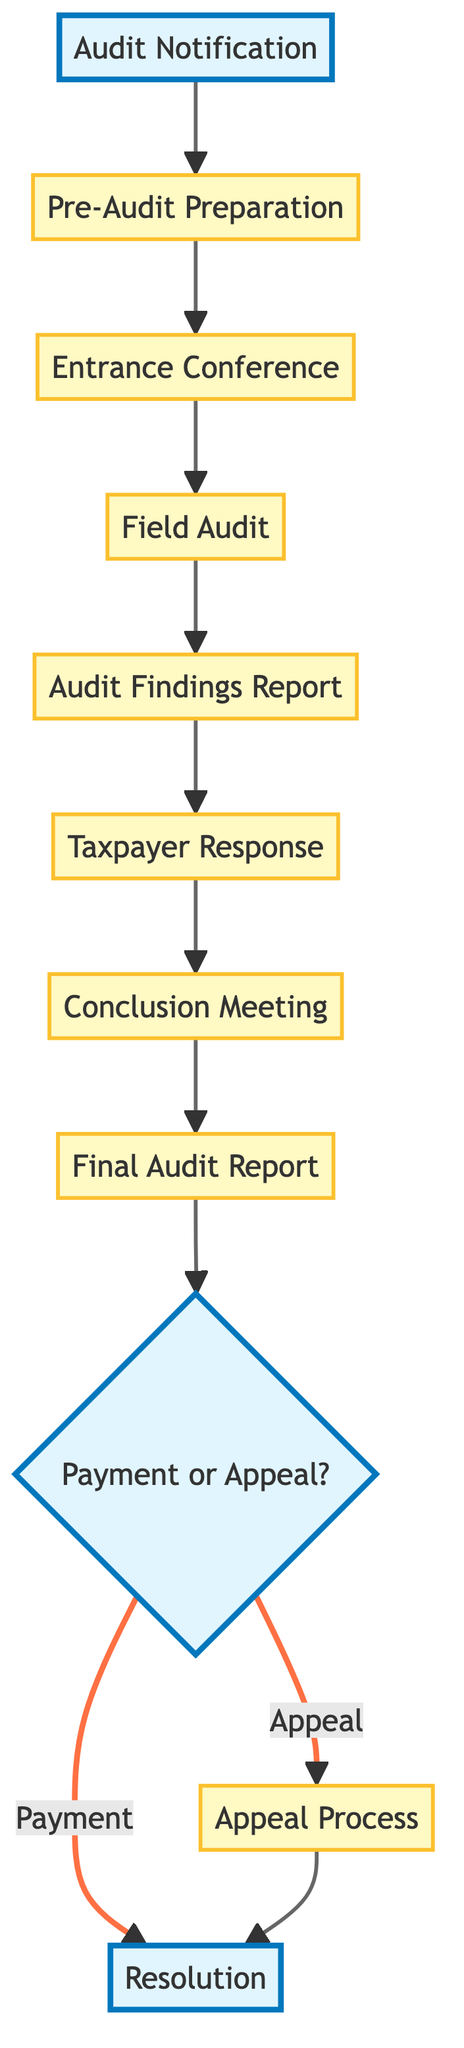What is the first stage of the tax audit procedure? The diagram indicates the first stage of the tax audit procedure is "Audit Notification," which is represented as the starting point in the flow chart.
Answer: Audit Notification How many stages are in the tax audit procedure? By counting the nodes in the flow chart, there are a total of 11 distinct stages listed, from "Audit Notification" to "Resolution."
Answer: 11 What happens after the "Field Audit"? According to the flow chart, after the "Field Audit" stage, the next stage is "Audit Findings Report," which follows directly in the flow.
Answer: Audit Findings Report Is "Final Audit Report" before or after "Conclusion Meeting"? The diagram shows that "Final Audit Report" occurs after the "Conclusion Meeting," establishing the sequence of these two stages as "Conclusion Meeting" → "Final Audit Report."
Answer: After What are the possible outcomes of the "Payment or Appeal" stage? The flow chart directly illustrates two paths out of the "Payment or Appeal" stage: one leads to "Resolution" if payment is made, and the other to "Appeal Process" if the taxpayer chooses to appeal.
Answer: Payment, Appeal What stages are highlighted in the diagram? The diagram highlights three stages in distinct styles: "Audit Notification," "Payment or Appeal," and "Resolution," making them visually prominent in the flow.
Answer: Audit Notification, Payment or Appeal, Resolution What is the last step in the audit procedure if the taxpayer chooses to appeal? If the taxpayer chooses to appeal, the last step in the audit procedure, as per the flow chart, would be the "Resolution" stage, which follows after the "Appeal Process."
Answer: Resolution Which stage involves the initial meeting with the auditor? The "Entrance Conference" stage, as per the diagram, describes the initial meeting between the tax auditor and the taxpayer, making it clear that this is where they discuss the audit process.
Answer: Entrance Conference In which stage does the taxpayer provide their response to findings? The diagram shows that the taxpayer provides their response to the findings in the "Taxpayer Response" stage, highlighting its role in the audit procedure.
Answer: Taxpayer Response 